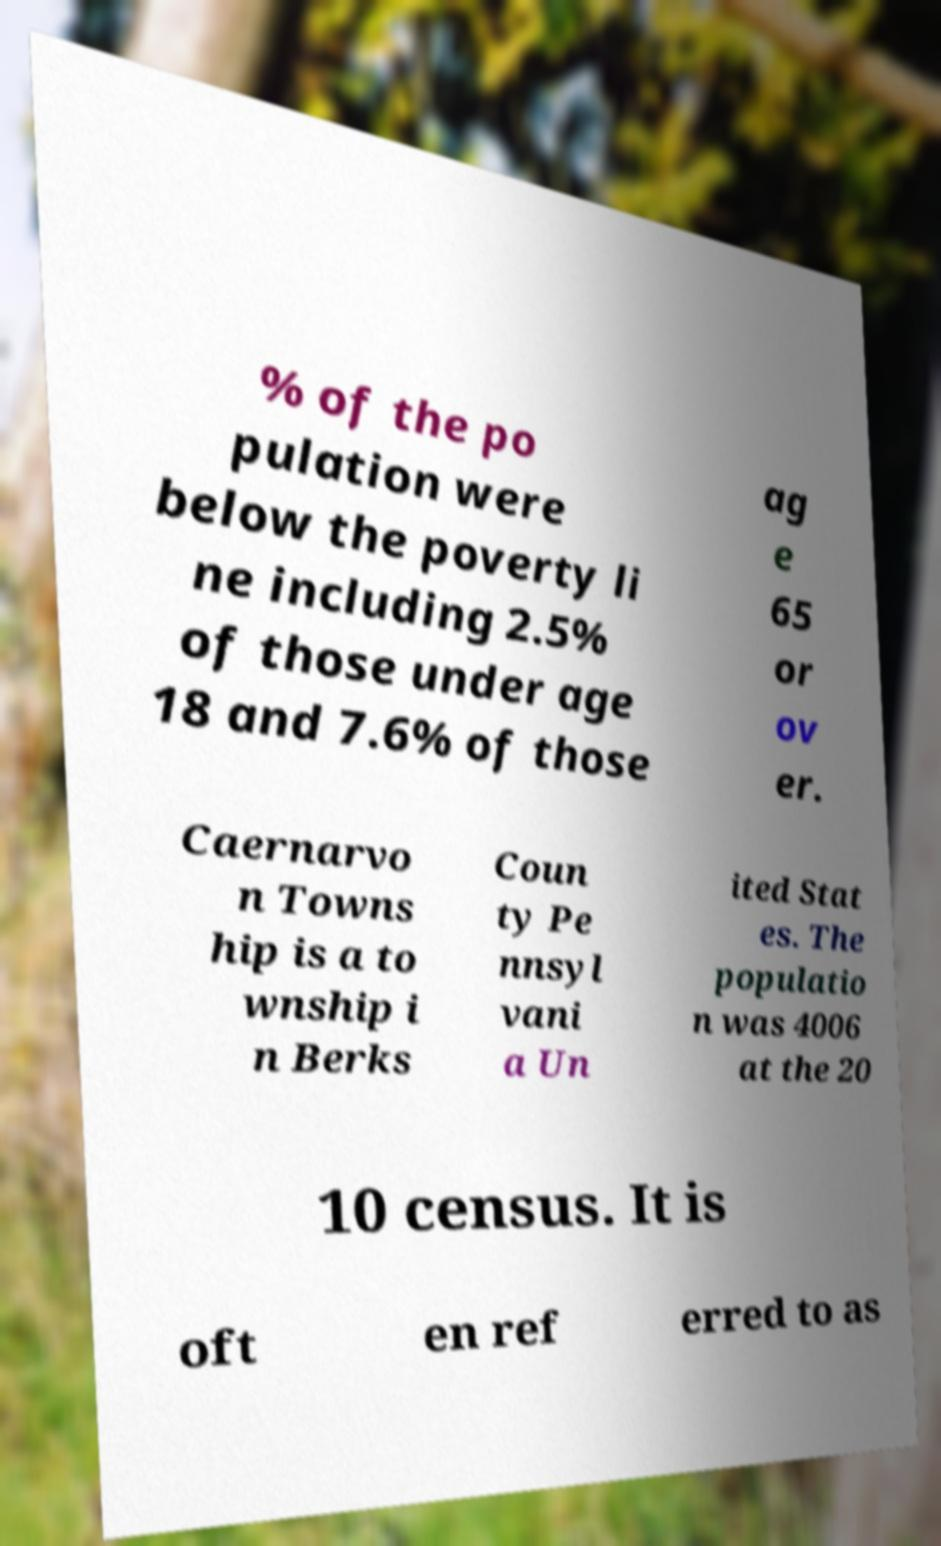For documentation purposes, I need the text within this image transcribed. Could you provide that? % of the po pulation were below the poverty li ne including 2.5% of those under age 18 and 7.6% of those ag e 65 or ov er. Caernarvo n Towns hip is a to wnship i n Berks Coun ty Pe nnsyl vani a Un ited Stat es. The populatio n was 4006 at the 20 10 census. It is oft en ref erred to as 